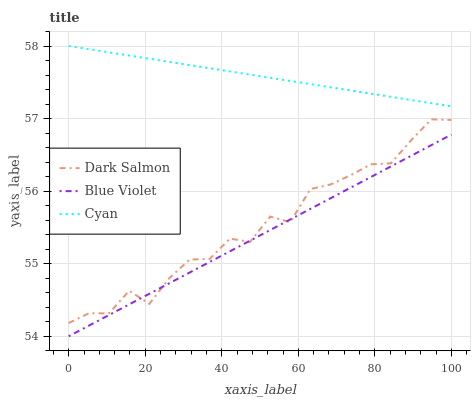Does Blue Violet have the minimum area under the curve?
Answer yes or no. Yes. Does Cyan have the maximum area under the curve?
Answer yes or no. Yes. Does Dark Salmon have the minimum area under the curve?
Answer yes or no. No. Does Dark Salmon have the maximum area under the curve?
Answer yes or no. No. Is Cyan the smoothest?
Answer yes or no. Yes. Is Dark Salmon the roughest?
Answer yes or no. Yes. Is Blue Violet the smoothest?
Answer yes or no. No. Is Blue Violet the roughest?
Answer yes or no. No. Does Blue Violet have the lowest value?
Answer yes or no. Yes. Does Dark Salmon have the lowest value?
Answer yes or no. No. Does Cyan have the highest value?
Answer yes or no. Yes. Does Dark Salmon have the highest value?
Answer yes or no. No. Is Dark Salmon less than Cyan?
Answer yes or no. Yes. Is Cyan greater than Blue Violet?
Answer yes or no. Yes. Does Dark Salmon intersect Blue Violet?
Answer yes or no. Yes. Is Dark Salmon less than Blue Violet?
Answer yes or no. No. Is Dark Salmon greater than Blue Violet?
Answer yes or no. No. Does Dark Salmon intersect Cyan?
Answer yes or no. No. 